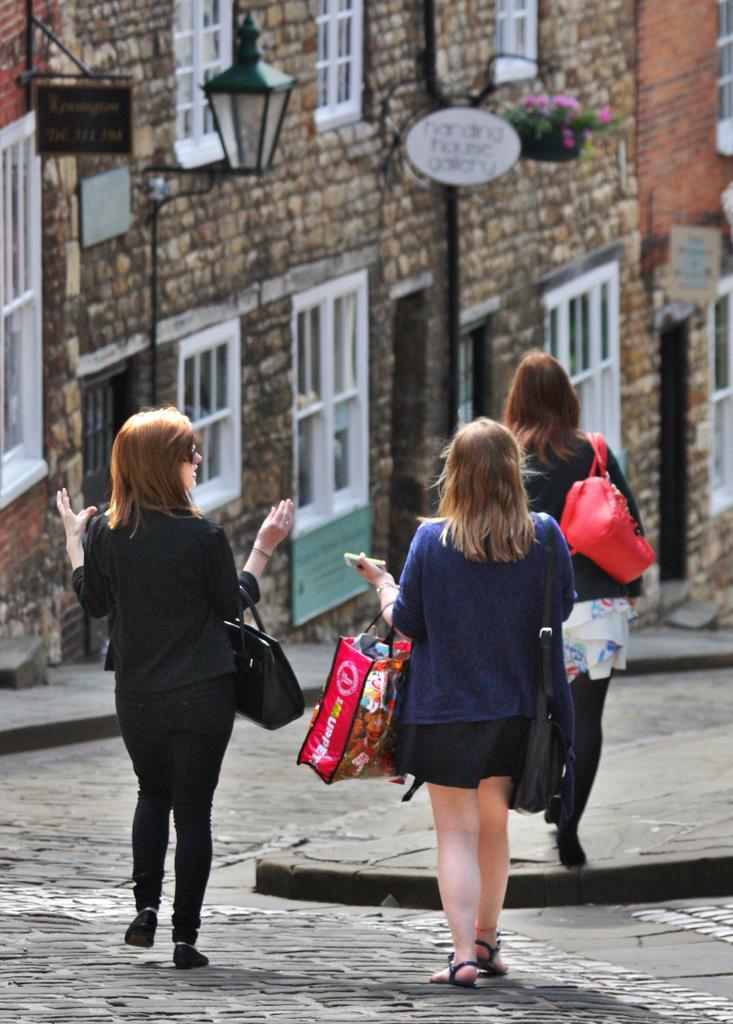Could you give a brief overview of what you see in this image? In the foreground of the picture there are three women holding bags and walking down the road. In the background there are buildings, street light, boards, flower pots and windows. 